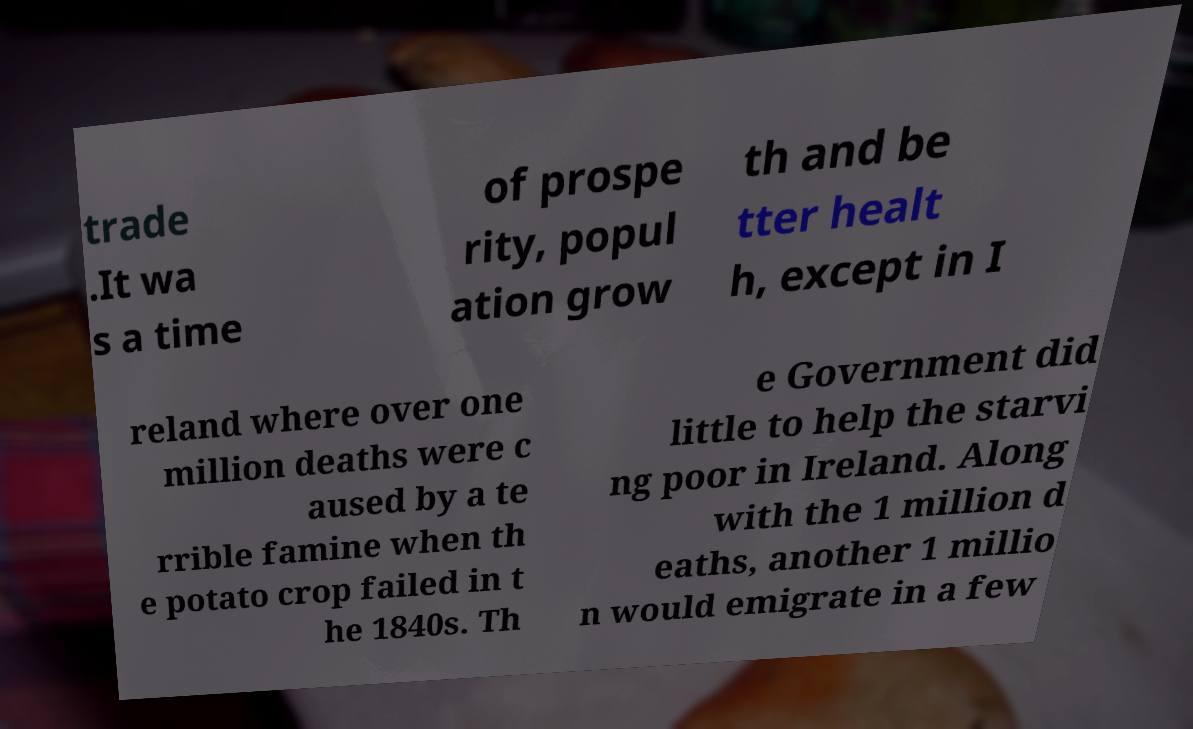Can you accurately transcribe the text from the provided image for me? trade .It wa s a time of prospe rity, popul ation grow th and be tter healt h, except in I reland where over one million deaths were c aused by a te rrible famine when th e potato crop failed in t he 1840s. Th e Government did little to help the starvi ng poor in Ireland. Along with the 1 million d eaths, another 1 millio n would emigrate in a few 